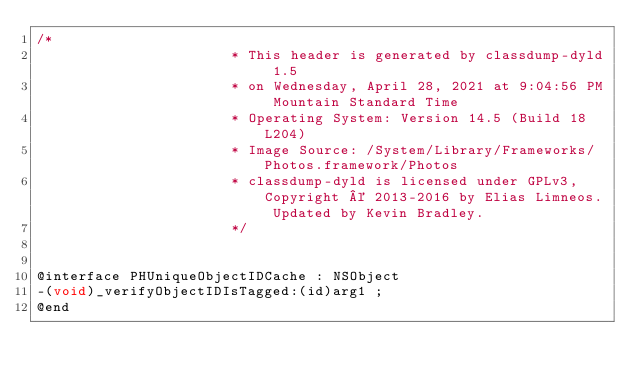Convert code to text. <code><loc_0><loc_0><loc_500><loc_500><_C_>/*
                       * This header is generated by classdump-dyld 1.5
                       * on Wednesday, April 28, 2021 at 9:04:56 PM Mountain Standard Time
                       * Operating System: Version 14.5 (Build 18L204)
                       * Image Source: /System/Library/Frameworks/Photos.framework/Photos
                       * classdump-dyld is licensed under GPLv3, Copyright © 2013-2016 by Elias Limneos. Updated by Kevin Bradley.
                       */


@interface PHUniqueObjectIDCache : NSObject
-(void)_verifyObjectIDIsTagged:(id)arg1 ;
@end

</code> 